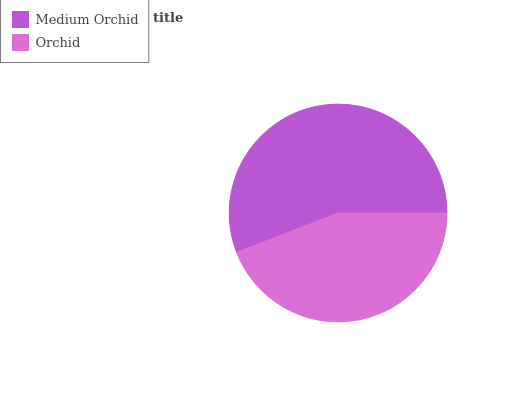Is Orchid the minimum?
Answer yes or no. Yes. Is Medium Orchid the maximum?
Answer yes or no. Yes. Is Orchid the maximum?
Answer yes or no. No. Is Medium Orchid greater than Orchid?
Answer yes or no. Yes. Is Orchid less than Medium Orchid?
Answer yes or no. Yes. Is Orchid greater than Medium Orchid?
Answer yes or no. No. Is Medium Orchid less than Orchid?
Answer yes or no. No. Is Medium Orchid the high median?
Answer yes or no. Yes. Is Orchid the low median?
Answer yes or no. Yes. Is Orchid the high median?
Answer yes or no. No. Is Medium Orchid the low median?
Answer yes or no. No. 